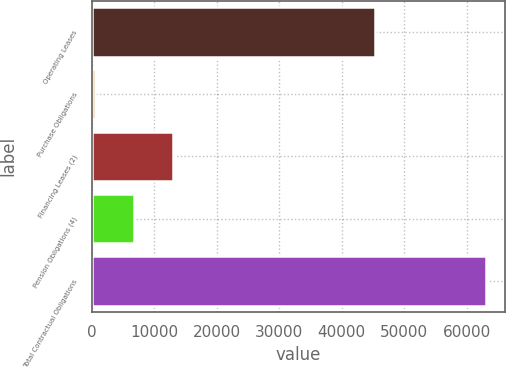Convert chart to OTSL. <chart><loc_0><loc_0><loc_500><loc_500><bar_chart><fcel>Operating Leases<fcel>Purchase Obligations<fcel>Financing Leases (2)<fcel>Pension Obligations (4)<fcel>Total Contractual Obligations<nl><fcel>45326<fcel>554<fcel>13048<fcel>6801<fcel>63024<nl></chart> 